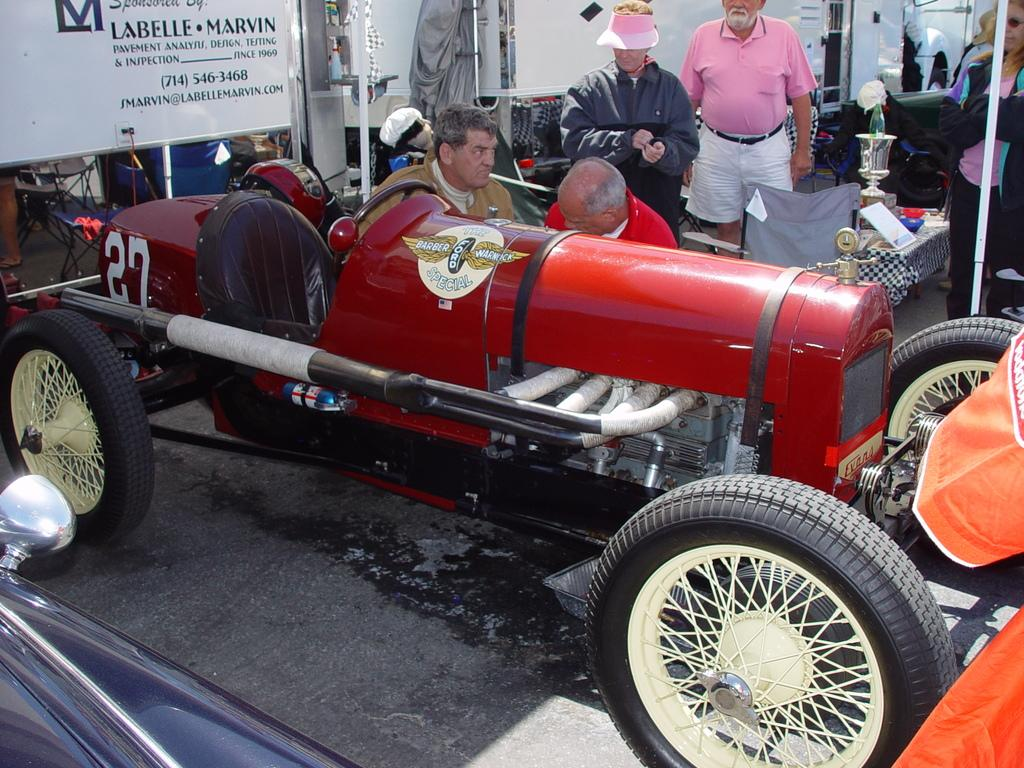What can be seen in the background of the image? There are white boards and people standing in the background of the image. What are the men in the image doing? The men are sitting in the image. What is near the men who are sitting? The men are sitting near a red color vehicle. What is on the table in the image? There is a board on the table, and there are other objects on the table as well. What type of club is being used by the men in the image? There is no club present in the image; the men are sitting near a red color vehicle. What color is the sweater worn by the person in the image? There is no sweater mentioned in the image; the focus is on the men sitting near the red color vehicle and the objects on the table. 